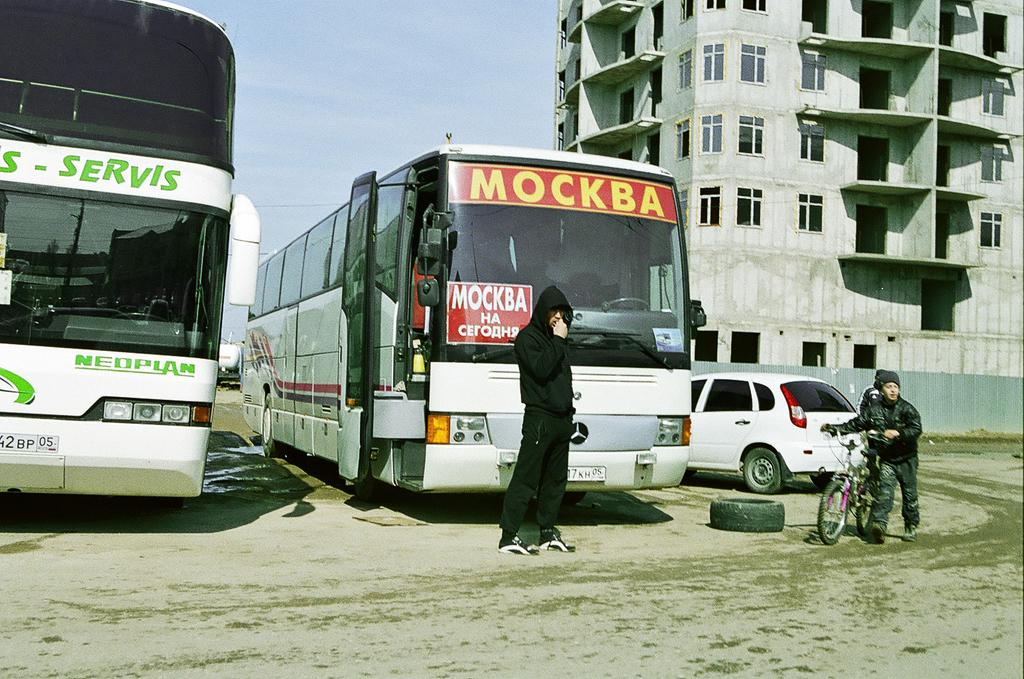Provide a one-sentence caption for the provided image. A city bus that says  MOCKBA across the front. 